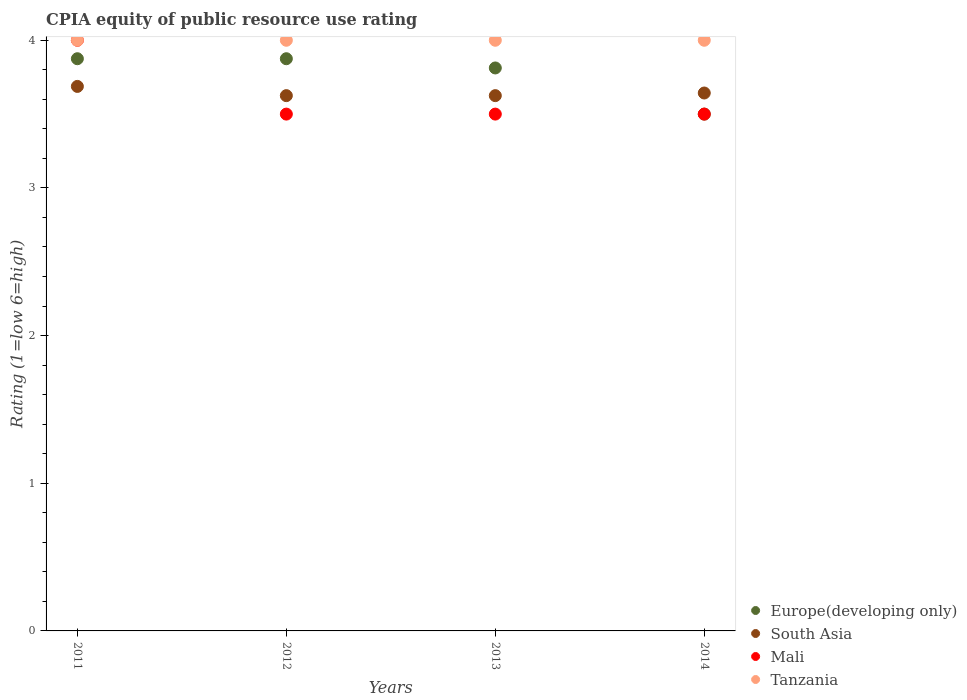How many different coloured dotlines are there?
Offer a terse response. 4. Is the number of dotlines equal to the number of legend labels?
Your response must be concise. Yes. What is the CPIA rating in Tanzania in 2011?
Provide a succinct answer. 4. Across all years, what is the maximum CPIA rating in South Asia?
Provide a short and direct response. 3.69. Across all years, what is the minimum CPIA rating in Tanzania?
Your response must be concise. 4. In which year was the CPIA rating in Mali maximum?
Make the answer very short. 2011. What is the total CPIA rating in Tanzania in the graph?
Your answer should be compact. 16. What is the difference between the CPIA rating in Tanzania in 2011 and that in 2012?
Provide a short and direct response. 0. What is the difference between the CPIA rating in Europe(developing only) in 2013 and the CPIA rating in Mali in 2014?
Make the answer very short. 0.31. What is the average CPIA rating in Mali per year?
Provide a succinct answer. 3.62. In the year 2012, what is the difference between the CPIA rating in South Asia and CPIA rating in Tanzania?
Keep it short and to the point. -0.38. In how many years, is the CPIA rating in Mali greater than 3.4?
Make the answer very short. 4. What is the ratio of the CPIA rating in South Asia in 2011 to that in 2013?
Your answer should be very brief. 1.02. What is the difference between the highest and the lowest CPIA rating in Mali?
Your response must be concise. 0.5. In how many years, is the CPIA rating in Tanzania greater than the average CPIA rating in Tanzania taken over all years?
Your response must be concise. 0. Does the CPIA rating in Europe(developing only) monotonically increase over the years?
Offer a very short reply. No. Is the CPIA rating in Europe(developing only) strictly greater than the CPIA rating in Tanzania over the years?
Your answer should be compact. No. How many dotlines are there?
Offer a terse response. 4. How many years are there in the graph?
Your answer should be very brief. 4. Are the values on the major ticks of Y-axis written in scientific E-notation?
Your answer should be compact. No. Does the graph contain any zero values?
Ensure brevity in your answer.  No. How many legend labels are there?
Your answer should be compact. 4. How are the legend labels stacked?
Ensure brevity in your answer.  Vertical. What is the title of the graph?
Your response must be concise. CPIA equity of public resource use rating. Does "Slovenia" appear as one of the legend labels in the graph?
Offer a very short reply. No. What is the label or title of the Y-axis?
Make the answer very short. Rating (1=low 6=high). What is the Rating (1=low 6=high) of Europe(developing only) in 2011?
Give a very brief answer. 3.88. What is the Rating (1=low 6=high) of South Asia in 2011?
Your answer should be very brief. 3.69. What is the Rating (1=low 6=high) of Mali in 2011?
Offer a very short reply. 4. What is the Rating (1=low 6=high) in Tanzania in 2011?
Offer a terse response. 4. What is the Rating (1=low 6=high) of Europe(developing only) in 2012?
Offer a very short reply. 3.88. What is the Rating (1=low 6=high) in South Asia in 2012?
Keep it short and to the point. 3.62. What is the Rating (1=low 6=high) of Europe(developing only) in 2013?
Offer a terse response. 3.81. What is the Rating (1=low 6=high) in South Asia in 2013?
Ensure brevity in your answer.  3.62. What is the Rating (1=low 6=high) in Europe(developing only) in 2014?
Make the answer very short. 3.5. What is the Rating (1=low 6=high) in South Asia in 2014?
Provide a succinct answer. 3.64. What is the Rating (1=low 6=high) of Mali in 2014?
Offer a very short reply. 3.5. Across all years, what is the maximum Rating (1=low 6=high) in Europe(developing only)?
Give a very brief answer. 3.88. Across all years, what is the maximum Rating (1=low 6=high) of South Asia?
Offer a very short reply. 3.69. Across all years, what is the maximum Rating (1=low 6=high) in Tanzania?
Your answer should be compact. 4. Across all years, what is the minimum Rating (1=low 6=high) of South Asia?
Keep it short and to the point. 3.62. Across all years, what is the minimum Rating (1=low 6=high) in Mali?
Your response must be concise. 3.5. What is the total Rating (1=low 6=high) of Europe(developing only) in the graph?
Offer a very short reply. 15.06. What is the total Rating (1=low 6=high) in South Asia in the graph?
Give a very brief answer. 14.58. What is the total Rating (1=low 6=high) in Mali in the graph?
Make the answer very short. 14.5. What is the total Rating (1=low 6=high) of Tanzania in the graph?
Give a very brief answer. 16. What is the difference between the Rating (1=low 6=high) in South Asia in 2011 and that in 2012?
Ensure brevity in your answer.  0.06. What is the difference between the Rating (1=low 6=high) of Mali in 2011 and that in 2012?
Provide a short and direct response. 0.5. What is the difference between the Rating (1=low 6=high) in Tanzania in 2011 and that in 2012?
Make the answer very short. 0. What is the difference between the Rating (1=low 6=high) in Europe(developing only) in 2011 and that in 2013?
Offer a terse response. 0.06. What is the difference between the Rating (1=low 6=high) of South Asia in 2011 and that in 2013?
Your answer should be very brief. 0.06. What is the difference between the Rating (1=low 6=high) of Tanzania in 2011 and that in 2013?
Provide a short and direct response. 0. What is the difference between the Rating (1=low 6=high) in Europe(developing only) in 2011 and that in 2014?
Keep it short and to the point. 0.38. What is the difference between the Rating (1=low 6=high) in South Asia in 2011 and that in 2014?
Your answer should be compact. 0.04. What is the difference between the Rating (1=low 6=high) in Tanzania in 2011 and that in 2014?
Make the answer very short. 0. What is the difference between the Rating (1=low 6=high) in Europe(developing only) in 2012 and that in 2013?
Keep it short and to the point. 0.06. What is the difference between the Rating (1=low 6=high) of South Asia in 2012 and that in 2013?
Offer a very short reply. 0. What is the difference between the Rating (1=low 6=high) of Mali in 2012 and that in 2013?
Your answer should be compact. 0. What is the difference between the Rating (1=low 6=high) in Tanzania in 2012 and that in 2013?
Give a very brief answer. 0. What is the difference between the Rating (1=low 6=high) of Europe(developing only) in 2012 and that in 2014?
Offer a very short reply. 0.38. What is the difference between the Rating (1=low 6=high) of South Asia in 2012 and that in 2014?
Offer a very short reply. -0.02. What is the difference between the Rating (1=low 6=high) in Tanzania in 2012 and that in 2014?
Offer a terse response. 0. What is the difference between the Rating (1=low 6=high) in Europe(developing only) in 2013 and that in 2014?
Offer a terse response. 0.31. What is the difference between the Rating (1=low 6=high) in South Asia in 2013 and that in 2014?
Provide a short and direct response. -0.02. What is the difference between the Rating (1=low 6=high) of Europe(developing only) in 2011 and the Rating (1=low 6=high) of Tanzania in 2012?
Offer a terse response. -0.12. What is the difference between the Rating (1=low 6=high) of South Asia in 2011 and the Rating (1=low 6=high) of Mali in 2012?
Your answer should be very brief. 0.19. What is the difference between the Rating (1=low 6=high) in South Asia in 2011 and the Rating (1=low 6=high) in Tanzania in 2012?
Give a very brief answer. -0.31. What is the difference between the Rating (1=low 6=high) of Europe(developing only) in 2011 and the Rating (1=low 6=high) of Mali in 2013?
Your answer should be compact. 0.38. What is the difference between the Rating (1=low 6=high) in Europe(developing only) in 2011 and the Rating (1=low 6=high) in Tanzania in 2013?
Provide a short and direct response. -0.12. What is the difference between the Rating (1=low 6=high) in South Asia in 2011 and the Rating (1=low 6=high) in Mali in 2013?
Give a very brief answer. 0.19. What is the difference between the Rating (1=low 6=high) of South Asia in 2011 and the Rating (1=low 6=high) of Tanzania in 2013?
Offer a terse response. -0.31. What is the difference between the Rating (1=low 6=high) of Europe(developing only) in 2011 and the Rating (1=low 6=high) of South Asia in 2014?
Your response must be concise. 0.23. What is the difference between the Rating (1=low 6=high) of Europe(developing only) in 2011 and the Rating (1=low 6=high) of Mali in 2014?
Ensure brevity in your answer.  0.38. What is the difference between the Rating (1=low 6=high) in Europe(developing only) in 2011 and the Rating (1=low 6=high) in Tanzania in 2014?
Give a very brief answer. -0.12. What is the difference between the Rating (1=low 6=high) in South Asia in 2011 and the Rating (1=low 6=high) in Mali in 2014?
Your answer should be compact. 0.19. What is the difference between the Rating (1=low 6=high) in South Asia in 2011 and the Rating (1=low 6=high) in Tanzania in 2014?
Keep it short and to the point. -0.31. What is the difference between the Rating (1=low 6=high) of Europe(developing only) in 2012 and the Rating (1=low 6=high) of Mali in 2013?
Give a very brief answer. 0.38. What is the difference between the Rating (1=low 6=high) of Europe(developing only) in 2012 and the Rating (1=low 6=high) of Tanzania in 2013?
Provide a succinct answer. -0.12. What is the difference between the Rating (1=low 6=high) of South Asia in 2012 and the Rating (1=low 6=high) of Tanzania in 2013?
Offer a very short reply. -0.38. What is the difference between the Rating (1=low 6=high) of Mali in 2012 and the Rating (1=low 6=high) of Tanzania in 2013?
Offer a very short reply. -0.5. What is the difference between the Rating (1=low 6=high) in Europe(developing only) in 2012 and the Rating (1=low 6=high) in South Asia in 2014?
Ensure brevity in your answer.  0.23. What is the difference between the Rating (1=low 6=high) in Europe(developing only) in 2012 and the Rating (1=low 6=high) in Mali in 2014?
Offer a very short reply. 0.38. What is the difference between the Rating (1=low 6=high) of Europe(developing only) in 2012 and the Rating (1=low 6=high) of Tanzania in 2014?
Offer a terse response. -0.12. What is the difference between the Rating (1=low 6=high) in South Asia in 2012 and the Rating (1=low 6=high) in Tanzania in 2014?
Give a very brief answer. -0.38. What is the difference between the Rating (1=low 6=high) of Europe(developing only) in 2013 and the Rating (1=low 6=high) of South Asia in 2014?
Ensure brevity in your answer.  0.17. What is the difference between the Rating (1=low 6=high) in Europe(developing only) in 2013 and the Rating (1=low 6=high) in Mali in 2014?
Give a very brief answer. 0.31. What is the difference between the Rating (1=low 6=high) in Europe(developing only) in 2013 and the Rating (1=low 6=high) in Tanzania in 2014?
Offer a terse response. -0.19. What is the difference between the Rating (1=low 6=high) of South Asia in 2013 and the Rating (1=low 6=high) of Tanzania in 2014?
Make the answer very short. -0.38. What is the average Rating (1=low 6=high) in Europe(developing only) per year?
Keep it short and to the point. 3.77. What is the average Rating (1=low 6=high) of South Asia per year?
Give a very brief answer. 3.65. What is the average Rating (1=low 6=high) in Mali per year?
Keep it short and to the point. 3.62. In the year 2011, what is the difference between the Rating (1=low 6=high) of Europe(developing only) and Rating (1=low 6=high) of South Asia?
Your answer should be compact. 0.19. In the year 2011, what is the difference between the Rating (1=low 6=high) in Europe(developing only) and Rating (1=low 6=high) in Mali?
Ensure brevity in your answer.  -0.12. In the year 2011, what is the difference between the Rating (1=low 6=high) of Europe(developing only) and Rating (1=low 6=high) of Tanzania?
Your response must be concise. -0.12. In the year 2011, what is the difference between the Rating (1=low 6=high) of South Asia and Rating (1=low 6=high) of Mali?
Make the answer very short. -0.31. In the year 2011, what is the difference between the Rating (1=low 6=high) of South Asia and Rating (1=low 6=high) of Tanzania?
Provide a short and direct response. -0.31. In the year 2011, what is the difference between the Rating (1=low 6=high) in Mali and Rating (1=low 6=high) in Tanzania?
Your answer should be compact. 0. In the year 2012, what is the difference between the Rating (1=low 6=high) of Europe(developing only) and Rating (1=low 6=high) of Mali?
Your answer should be very brief. 0.38. In the year 2012, what is the difference between the Rating (1=low 6=high) of Europe(developing only) and Rating (1=low 6=high) of Tanzania?
Your answer should be very brief. -0.12. In the year 2012, what is the difference between the Rating (1=low 6=high) in South Asia and Rating (1=low 6=high) in Tanzania?
Ensure brevity in your answer.  -0.38. In the year 2013, what is the difference between the Rating (1=low 6=high) in Europe(developing only) and Rating (1=low 6=high) in South Asia?
Keep it short and to the point. 0.19. In the year 2013, what is the difference between the Rating (1=low 6=high) in Europe(developing only) and Rating (1=low 6=high) in Mali?
Ensure brevity in your answer.  0.31. In the year 2013, what is the difference between the Rating (1=low 6=high) of Europe(developing only) and Rating (1=low 6=high) of Tanzania?
Offer a terse response. -0.19. In the year 2013, what is the difference between the Rating (1=low 6=high) of South Asia and Rating (1=low 6=high) of Tanzania?
Keep it short and to the point. -0.38. In the year 2013, what is the difference between the Rating (1=low 6=high) of Mali and Rating (1=low 6=high) of Tanzania?
Your answer should be very brief. -0.5. In the year 2014, what is the difference between the Rating (1=low 6=high) in Europe(developing only) and Rating (1=low 6=high) in South Asia?
Provide a short and direct response. -0.14. In the year 2014, what is the difference between the Rating (1=low 6=high) of South Asia and Rating (1=low 6=high) of Mali?
Offer a terse response. 0.14. In the year 2014, what is the difference between the Rating (1=low 6=high) of South Asia and Rating (1=low 6=high) of Tanzania?
Offer a terse response. -0.36. What is the ratio of the Rating (1=low 6=high) in South Asia in 2011 to that in 2012?
Offer a very short reply. 1.02. What is the ratio of the Rating (1=low 6=high) of Mali in 2011 to that in 2012?
Provide a succinct answer. 1.14. What is the ratio of the Rating (1=low 6=high) of Europe(developing only) in 2011 to that in 2013?
Your answer should be compact. 1.02. What is the ratio of the Rating (1=low 6=high) in South Asia in 2011 to that in 2013?
Offer a very short reply. 1.02. What is the ratio of the Rating (1=low 6=high) in Mali in 2011 to that in 2013?
Provide a succinct answer. 1.14. What is the ratio of the Rating (1=low 6=high) of Europe(developing only) in 2011 to that in 2014?
Provide a succinct answer. 1.11. What is the ratio of the Rating (1=low 6=high) of South Asia in 2011 to that in 2014?
Give a very brief answer. 1.01. What is the ratio of the Rating (1=low 6=high) in Europe(developing only) in 2012 to that in 2013?
Provide a short and direct response. 1.02. What is the ratio of the Rating (1=low 6=high) of Mali in 2012 to that in 2013?
Your response must be concise. 1. What is the ratio of the Rating (1=low 6=high) of Europe(developing only) in 2012 to that in 2014?
Ensure brevity in your answer.  1.11. What is the ratio of the Rating (1=low 6=high) in Mali in 2012 to that in 2014?
Offer a terse response. 1. What is the ratio of the Rating (1=low 6=high) of Tanzania in 2012 to that in 2014?
Give a very brief answer. 1. What is the ratio of the Rating (1=low 6=high) in Europe(developing only) in 2013 to that in 2014?
Your answer should be compact. 1.09. What is the ratio of the Rating (1=low 6=high) of Mali in 2013 to that in 2014?
Offer a very short reply. 1. What is the difference between the highest and the second highest Rating (1=low 6=high) in South Asia?
Your response must be concise. 0.04. What is the difference between the highest and the lowest Rating (1=low 6=high) in South Asia?
Provide a short and direct response. 0.06. What is the difference between the highest and the lowest Rating (1=low 6=high) of Mali?
Provide a succinct answer. 0.5. 